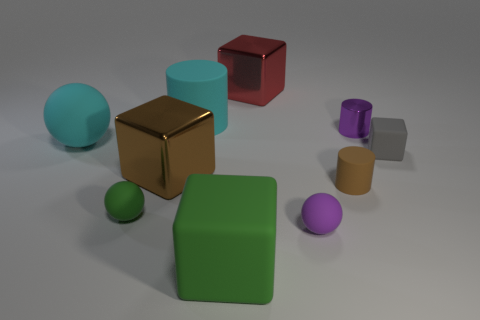Subtract all large brown blocks. How many blocks are left? 3 Subtract 1 cylinders. How many cylinders are left? 2 Subtract all brown cubes. How many cubes are left? 3 Subtract 0 blue cylinders. How many objects are left? 10 Subtract all blocks. How many objects are left? 6 Subtract all green cylinders. Subtract all red spheres. How many cylinders are left? 3 Subtract all large brown metal things. Subtract all tiny purple metallic cylinders. How many objects are left? 8 Add 1 big cylinders. How many big cylinders are left? 2 Add 1 big blue rubber cubes. How many big blue rubber cubes exist? 1 